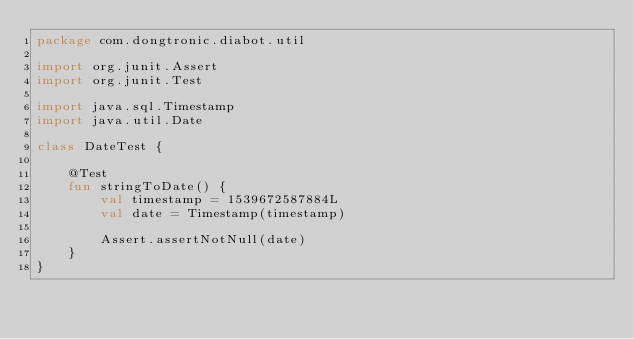Convert code to text. <code><loc_0><loc_0><loc_500><loc_500><_Kotlin_>package com.dongtronic.diabot.util

import org.junit.Assert
import org.junit.Test

import java.sql.Timestamp
import java.util.Date

class DateTest {

    @Test
    fun stringToDate() {
        val timestamp = 1539672587884L
        val date = Timestamp(timestamp)

        Assert.assertNotNull(date)
    }
}
</code> 